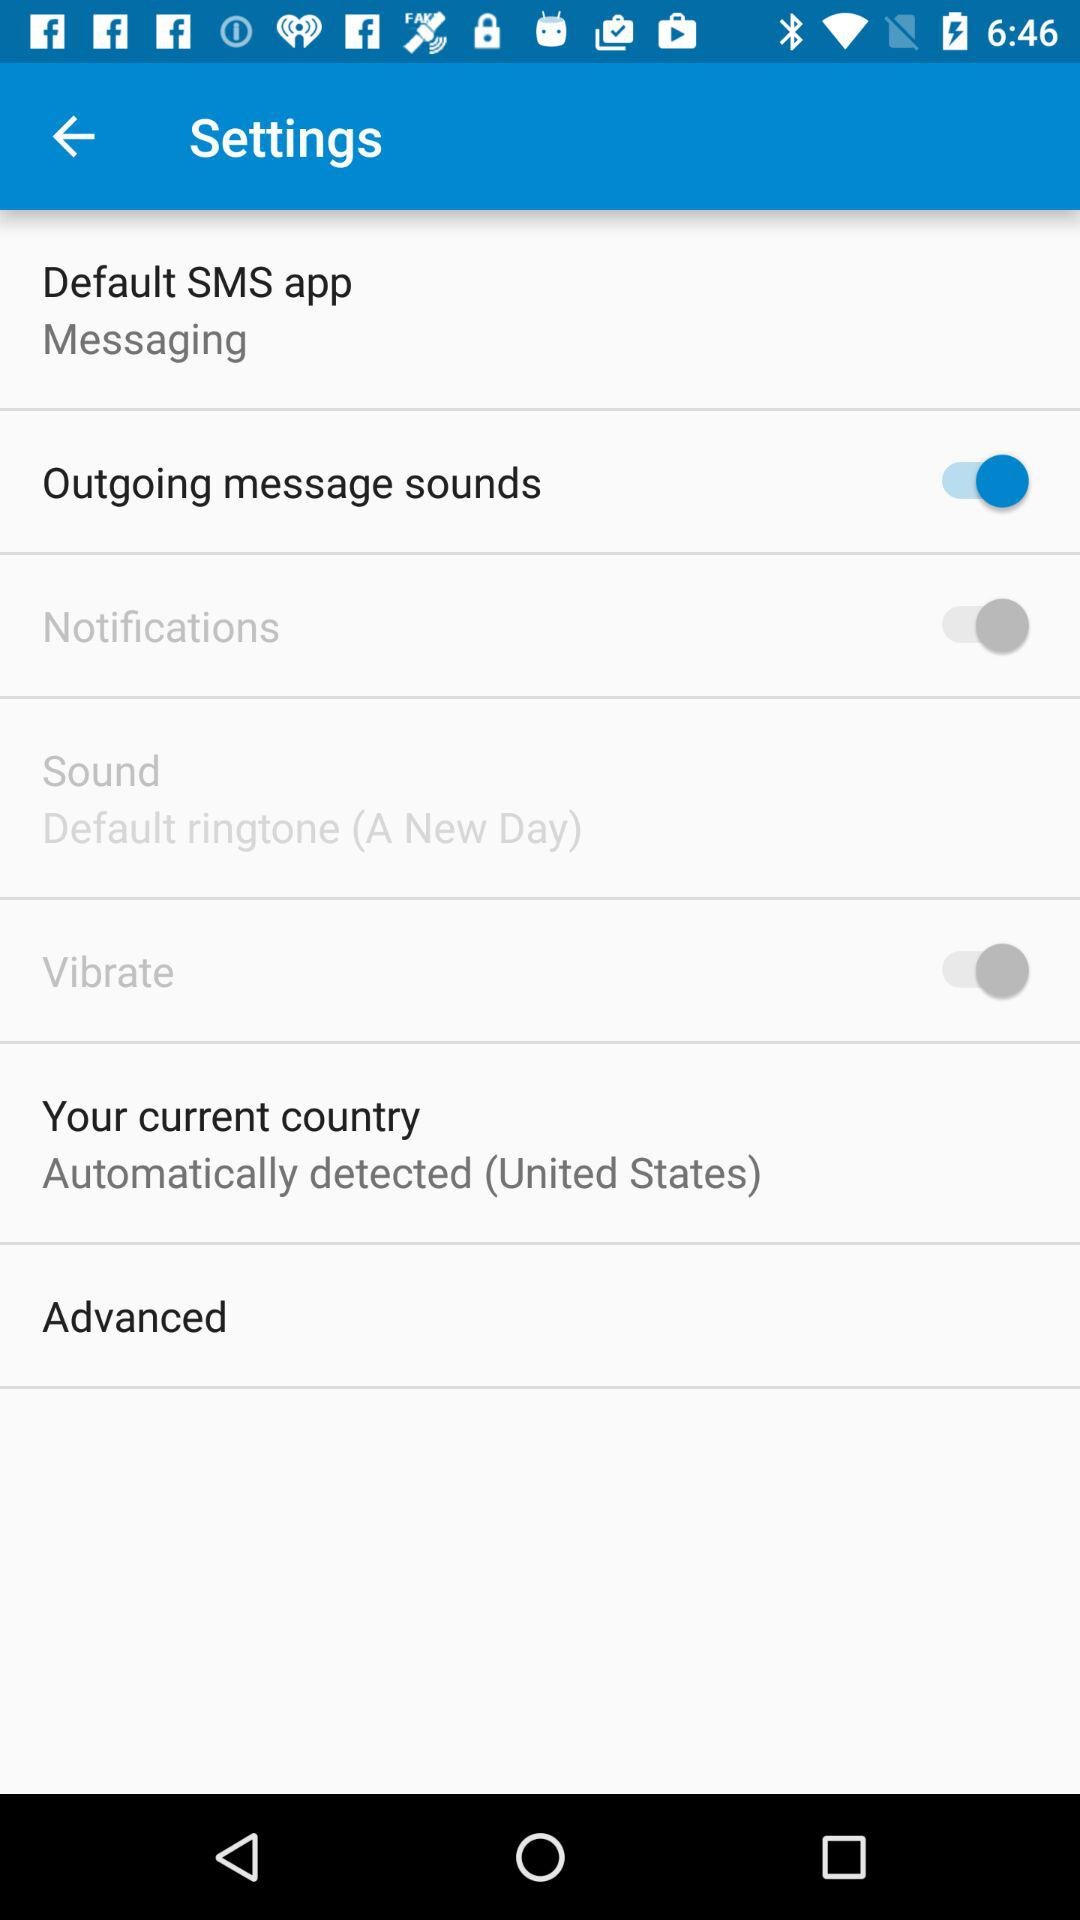How many switches are not enabled?
Answer the question using a single word or phrase. 2 